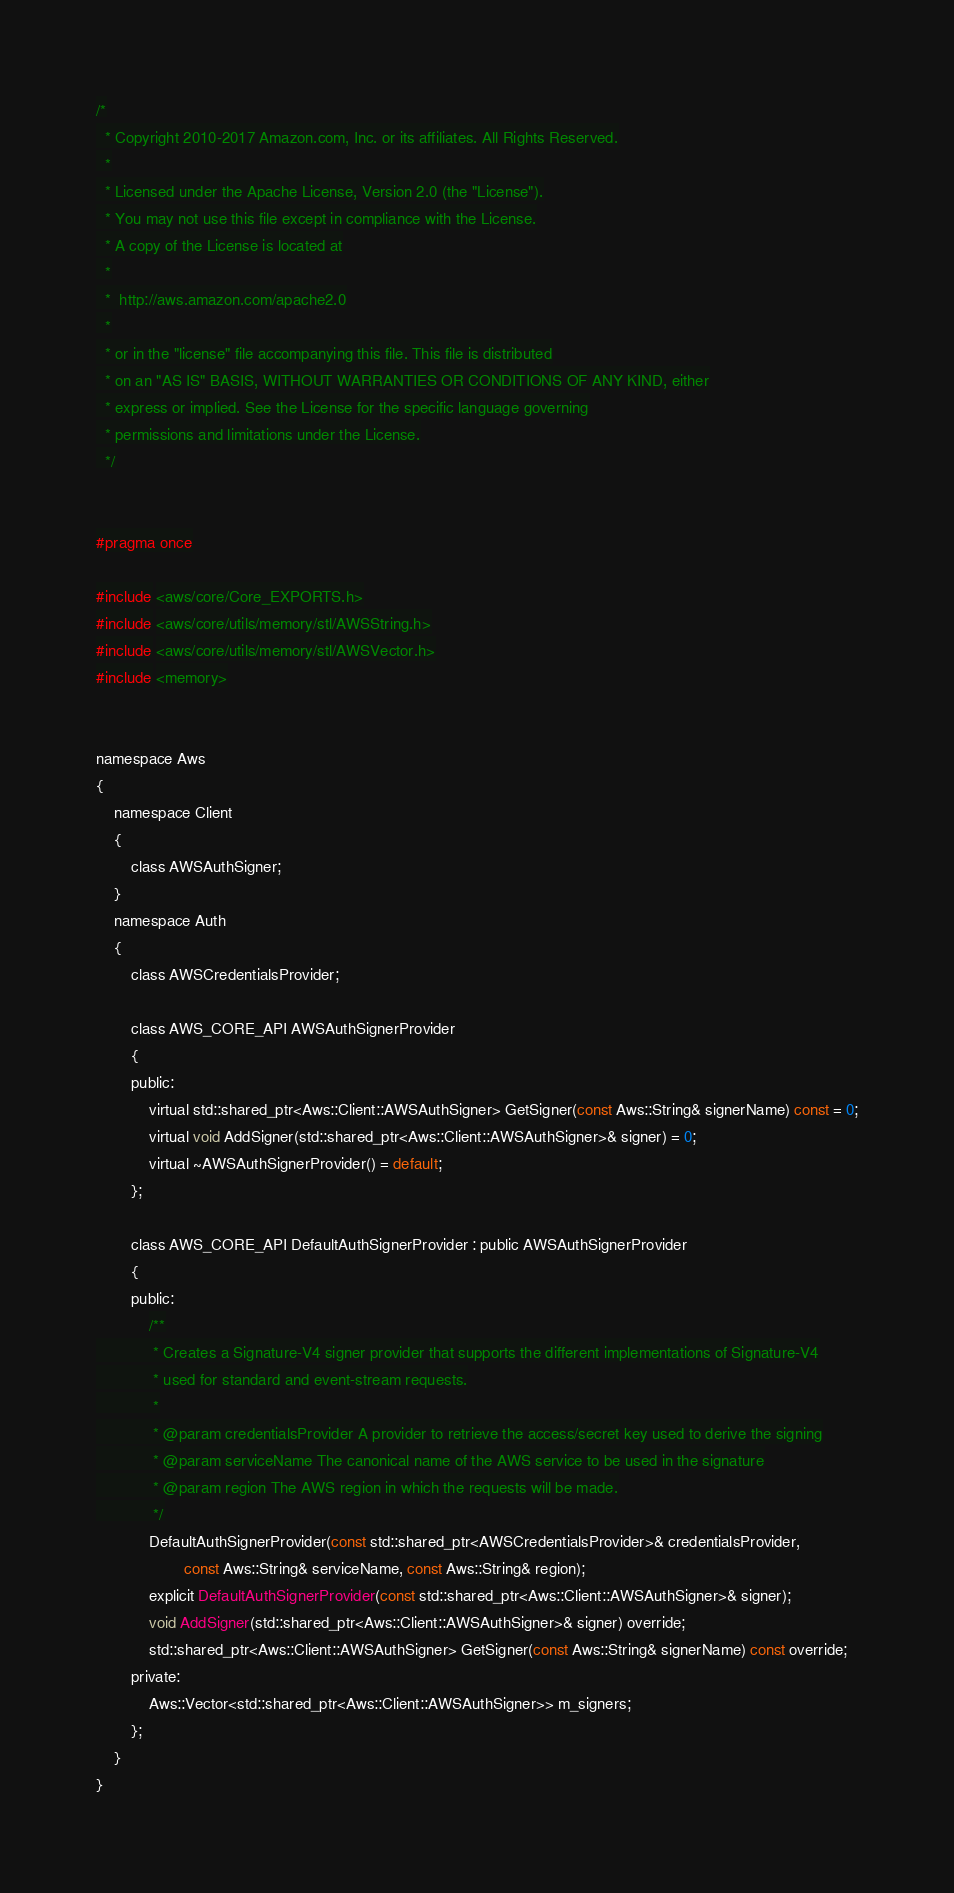<code> <loc_0><loc_0><loc_500><loc_500><_C_>/*
  * Copyright 2010-2017 Amazon.com, Inc. or its affiliates. All Rights Reserved.
  *
  * Licensed under the Apache License, Version 2.0 (the "License").
  * You may not use this file except in compliance with the License.
  * A copy of the License is located at
  *
  *  http://aws.amazon.com/apache2.0
  *
  * or in the "license" file accompanying this file. This file is distributed
  * on an "AS IS" BASIS, WITHOUT WARRANTIES OR CONDITIONS OF ANY KIND, either
  * express or implied. See the License for the specific language governing
  * permissions and limitations under the License.
  */


#pragma once

#include <aws/core/Core_EXPORTS.h>
#include <aws/core/utils/memory/stl/AWSString.h>
#include <aws/core/utils/memory/stl/AWSVector.h>
#include <memory>


namespace Aws
{
    namespace Client
    {
        class AWSAuthSigner;
    }
    namespace Auth
    {
        class AWSCredentialsProvider;

        class AWS_CORE_API AWSAuthSignerProvider
        {
        public:
            virtual std::shared_ptr<Aws::Client::AWSAuthSigner> GetSigner(const Aws::String& signerName) const = 0;
            virtual void AddSigner(std::shared_ptr<Aws::Client::AWSAuthSigner>& signer) = 0;
            virtual ~AWSAuthSignerProvider() = default;
        };

        class AWS_CORE_API DefaultAuthSignerProvider : public AWSAuthSignerProvider
        {
        public:
            /**
             * Creates a Signature-V4 signer provider that supports the different implementations of Signature-V4
             * used for standard and event-stream requests.
             *
             * @param credentialsProvider A provider to retrieve the access/secret key used to derive the signing
             * @param serviceName The canonical name of the AWS service to be used in the signature
             * @param region The AWS region in which the requests will be made.
             */
            DefaultAuthSignerProvider(const std::shared_ptr<AWSCredentialsProvider>& credentialsProvider,
                    const Aws::String& serviceName, const Aws::String& region);
            explicit DefaultAuthSignerProvider(const std::shared_ptr<Aws::Client::AWSAuthSigner>& signer);
            void AddSigner(std::shared_ptr<Aws::Client::AWSAuthSigner>& signer) override;
            std::shared_ptr<Aws::Client::AWSAuthSigner> GetSigner(const Aws::String& signerName) const override;
        private:
            Aws::Vector<std::shared_ptr<Aws::Client::AWSAuthSigner>> m_signers;
        };
    }
}
</code> 